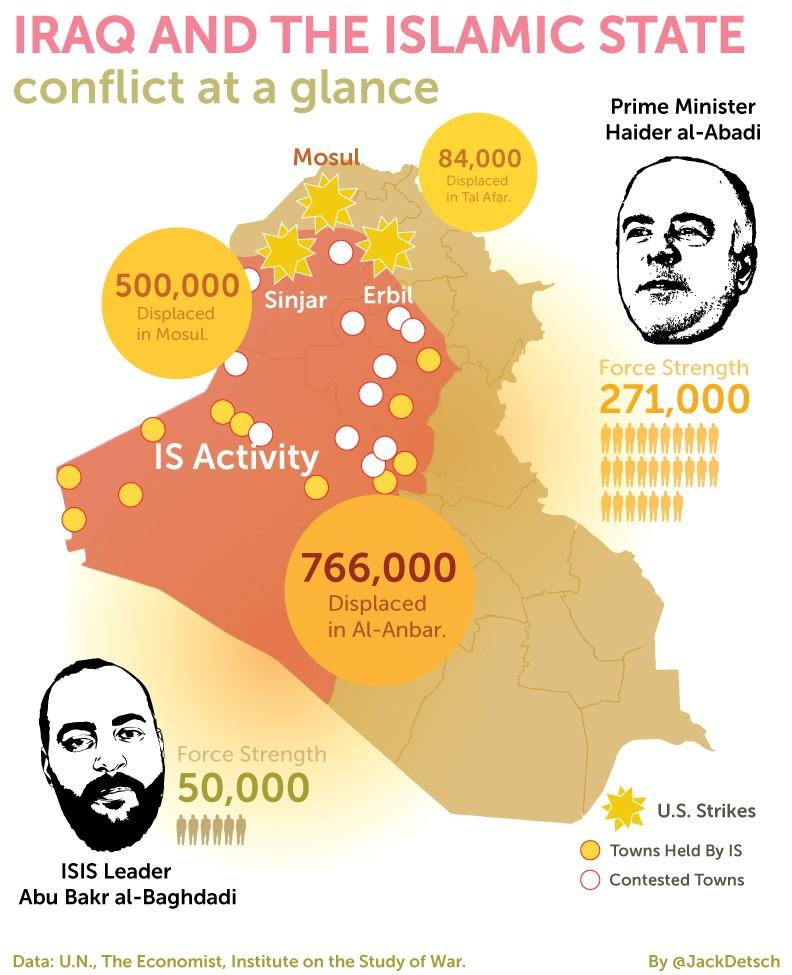Specify some key components in this picture. The person in the figure at the bottom is Abu Bakr al-Baghdadi. There are 12 contested towns. In Tal Afar and Mosul, there are a total of 584,000 displaced individuals who have been forced to flee their homes due to ongoing conflict and violence. ISIS currently controls 11 towns. The current Prime Minister of Iraq is Haider Al-Abadi. 